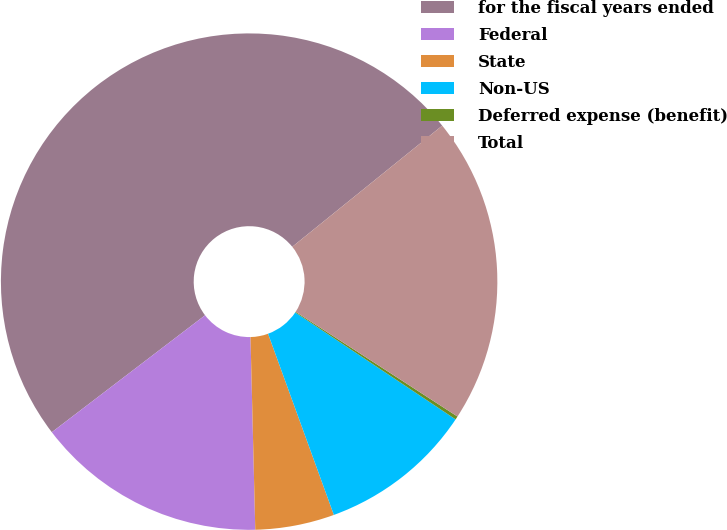Convert chart to OTSL. <chart><loc_0><loc_0><loc_500><loc_500><pie_chart><fcel>for the fiscal years ended<fcel>Federal<fcel>State<fcel>Non-US<fcel>Deferred expense (benefit)<fcel>Total<nl><fcel>49.56%<fcel>15.02%<fcel>5.15%<fcel>10.09%<fcel>0.22%<fcel>19.96%<nl></chart> 